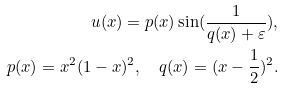Convert formula to latex. <formula><loc_0><loc_0><loc_500><loc_500>u ( x ) = p ( x ) \sin ( \frac { 1 } { q ( x ) + \varepsilon } ) , \\ p ( x ) = x ^ { 2 } ( 1 - x ) ^ { 2 } , \quad q ( x ) = ( x - \frac { 1 } { 2 } ) ^ { 2 } .</formula> 